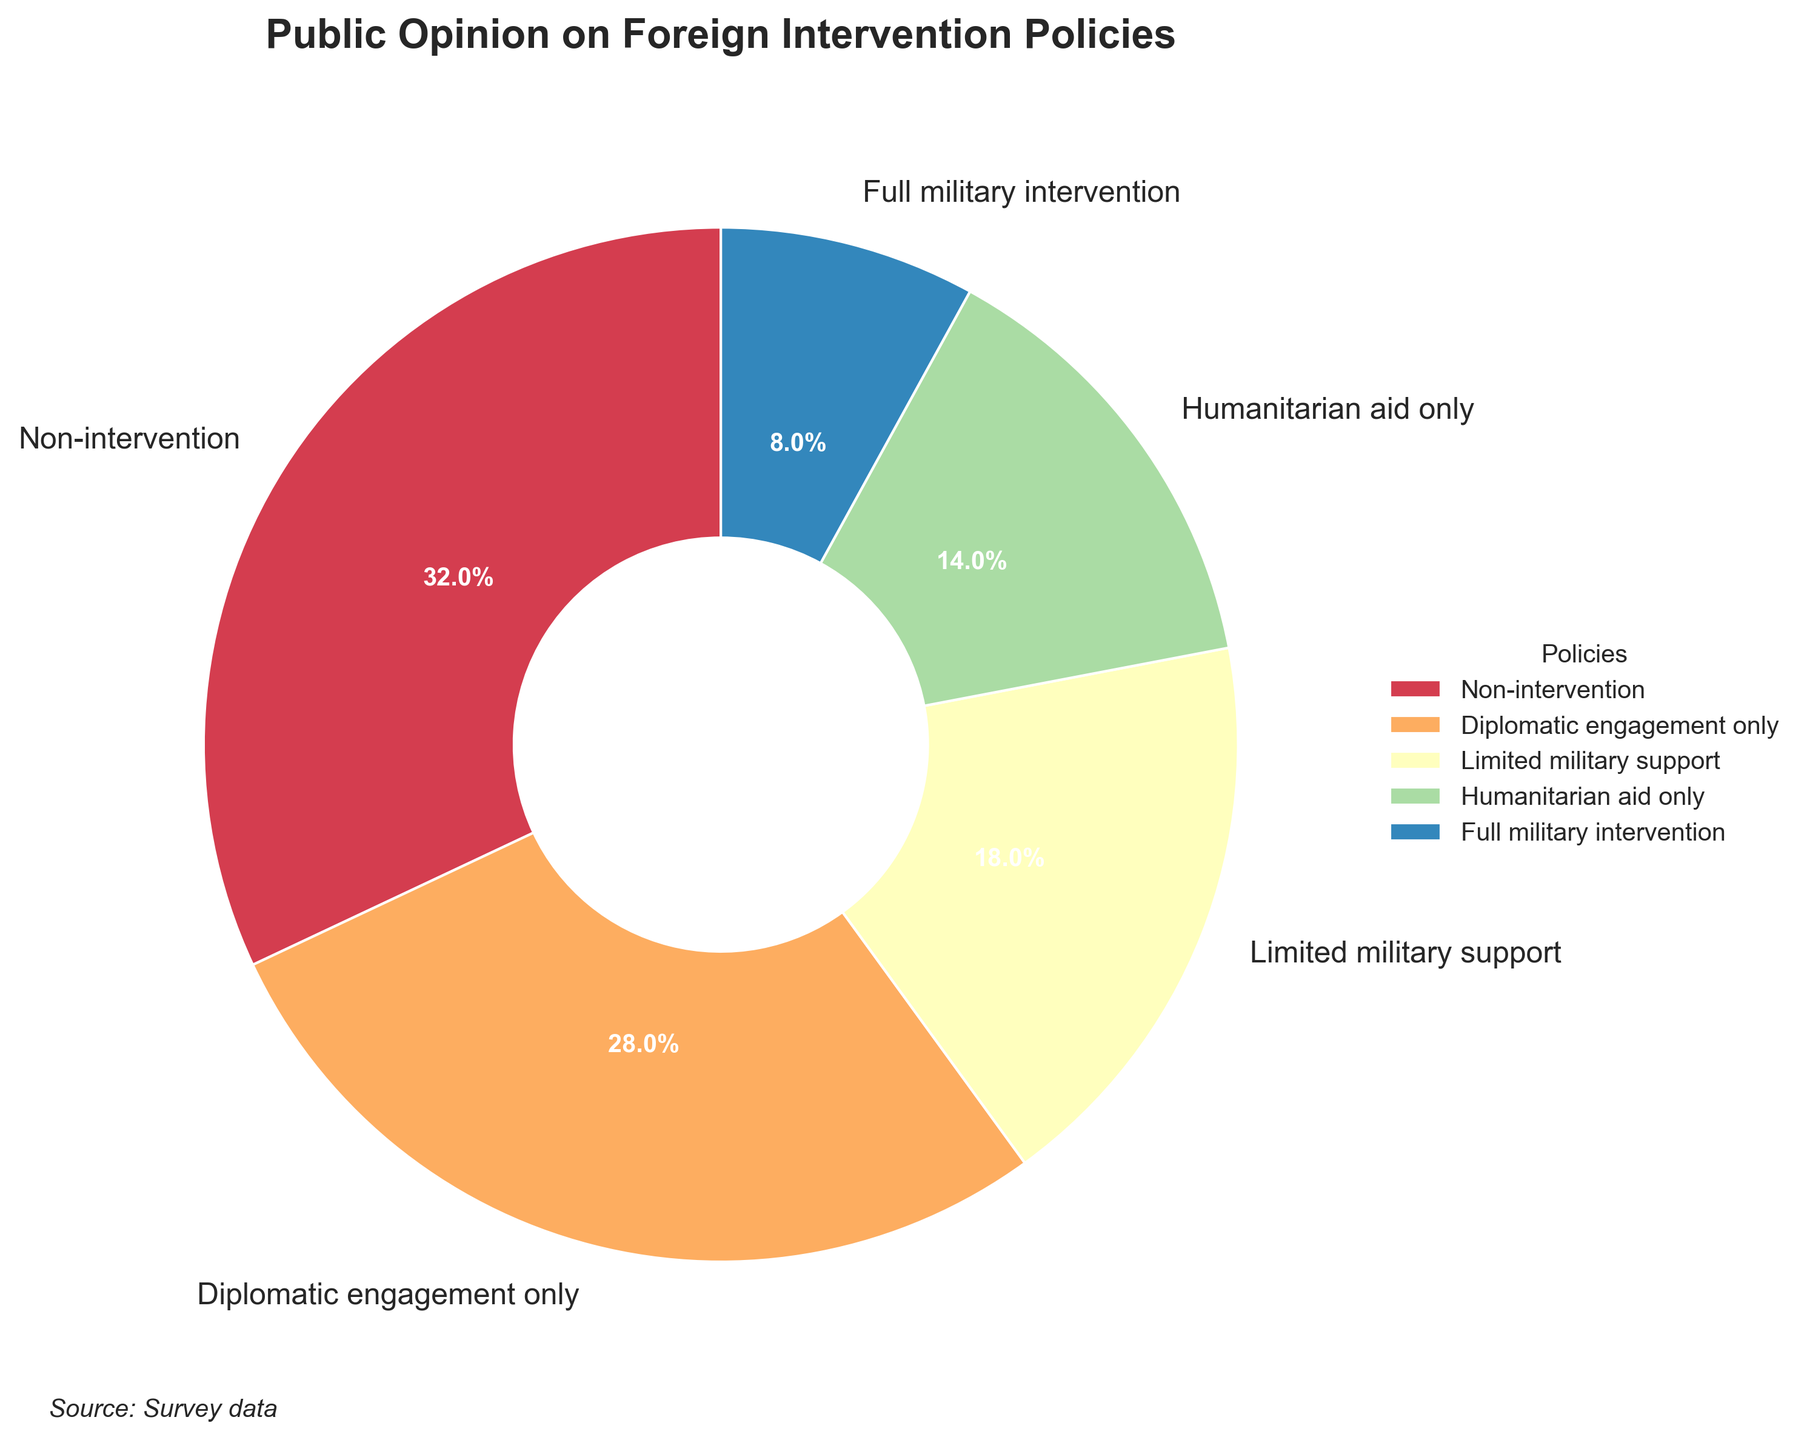Which policy has the highest percentage of public support? The wedges in the pie chart indicate different policies and their respective public support percentages. The policy labeled with the highest percentage is "Non-intervention" at 32%.
Answer: Non-intervention What's the combined percentage for Non-intervention and Diplomatic engagement only? Adding the percentages for Non-intervention (32%) and Diplomatic engagement only (28%): 32 + 28 = 60%
Answer: 60% Which one has a higher percentage: Limited military support or Humanitarian aid only? Comparing the percentages of Limited military support (18%) and Humanitarian aid only (14%), we see that Limited military support has a higher percentage.
Answer: Limited military support How does the public opinion on Full military intervention compare to Humanitarian aid only? Full military intervention has 8% public support, while Humanitarian aid only has 14%. Since 8% is less than 14%, Full military intervention has lower support.
Answer: Full military intervention is less supported Which one has the lowest percentage of public support and what is the percentage? The pie chart section with the smallest size represents the policy with the lowest support. The label shows "Full military intervention" at 8%.
Answer: Full military intervention, 8% What is the difference in percentage between Limited military support and Diplomatic engagement only? Subtract the percentage of Limited military support (18%) from Diplomatic engagement only (28%): 28 - 18 = 10%
Answer: 10% Is the percentage of Diplomatic engagement only greater than half the percentage of Non-intervention? Half of Non-intervention's 32% is 16%. Diplomatic engagement only has 28%, which is greater than 16%.
Answer: Yes What is the sum of the percentages for policies involving some form of intervention (Limited military support, Humanitarian aid only, Full military intervention)? Adding the percentages for Limited military support (18%), Humanitarian aid only (14%), and Full military intervention (8%): 18 + 14 + 8 = 40%
Answer: 40% Which policy is represented by the second-largest wedge in the pie chart? The second-largest wedge corresponds to "Diplomatic engagement only" at 28%.
Answer: Diplomatic engagement only What percentage does the segment colored most near the center represent? The pie chart shows wedges with a decreasing order of size from the center. The largest central wedge is Non-intervention at 32%.
Answer: 32% 